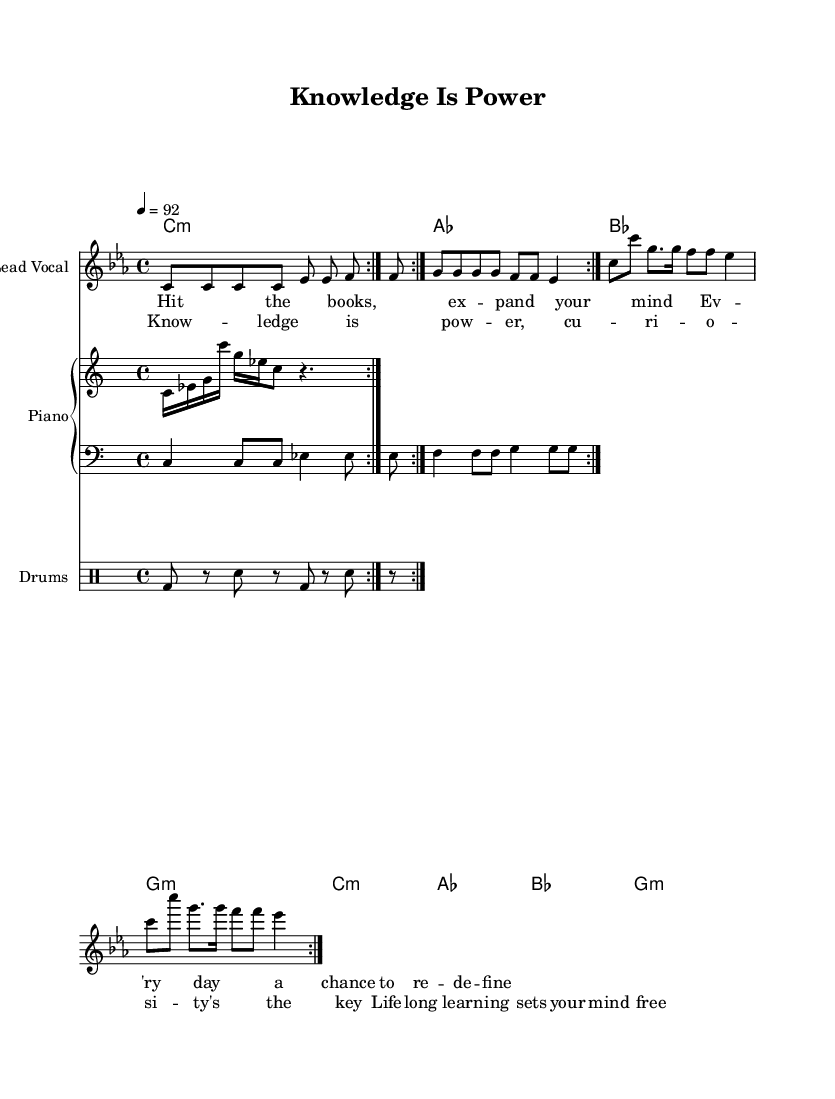What is the key signature of this music? The key signature is C minor, which has three flats indicated on the left side of the staff.
Answer: C minor What is the time signature of this music? The time signature is 4/4, which is shown at the beginning of the score and indicates four beats per measure.
Answer: 4/4 What is the tempo marking in this piece? The tempo marking is indicated as 92 beats per minute, shown at the beginning of the score as "4 = 92".
Answer: 92 How many times is the melody repeated in the verse? The melody is repeated twice, as indicated by the repeat signs (volta 2) at the beginning of the melody section.
Answer: 2 What are the lyrics of the chorus? The chorus lyrics are found in the specified section of the sheet music, specifically stating "Knowledge is power, curiosity's the key, Lifelong learning sets your mind free."
Answer: Knowledge is power, curiosity's the key, Lifelong learning sets your mind free What type of groove does the drum pattern suggest? The drum pattern suggests a consistent hip-hop groove due to the bass drum and snare arrangement, typical for rap music.
Answer: Hip-hop groove What type of harmony is primarily used in this piece? The harmony used primarily consists of minor chords, as indicated in the harmony section, which utilizes a pattern of C minor, A flat, B flat, and G minor chords.
Answer: Minor chords 